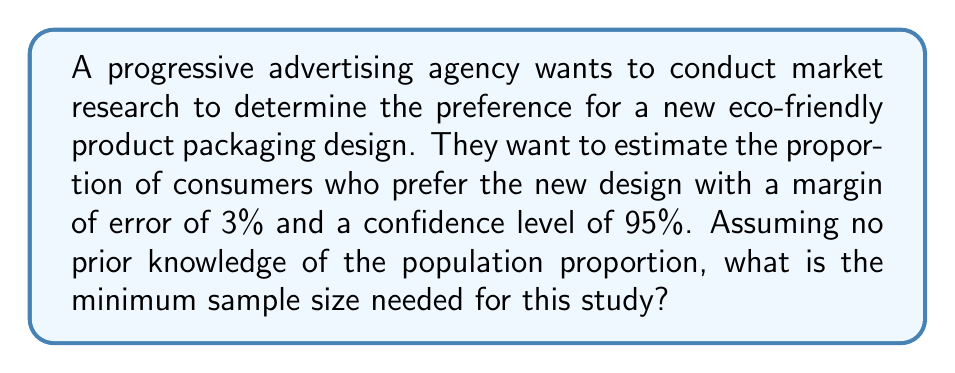Could you help me with this problem? To determine the optimal sample size for this market research, we'll use the formula for sample size calculation with a known margin of error and confidence level:

$$n = \frac{z^2 \cdot p(1-p)}{E^2}$$

Where:
$n$ = sample size
$z$ = z-score corresponding to the confidence level
$p$ = estimated population proportion
$E$ = margin of error

Step 1: Determine the z-score for a 95% confidence level.
For 95% confidence, $z = 1.96$

Step 2: Determine the margin of error.
$E = 0.03$ (3% expressed as a decimal)

Step 3: Determine the estimated population proportion.
Since we have no prior knowledge, we use $p = 0.5$ to maximize the sample size.

Step 4: Apply the formula:

$$n = \frac{1.96^2 \cdot 0.5(1-0.5)}{0.03^2}$$

$$n = \frac{3.8416 \cdot 0.25}{0.0009}$$

$$n = 1067.11$$

Step 5: Round up to the nearest whole number.
$n = 1068$

Therefore, the minimum sample size needed is 1068 consumers.
Answer: 1068 consumers 